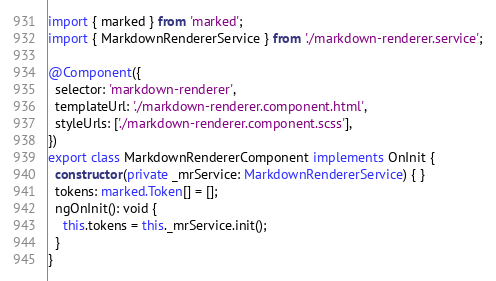<code> <loc_0><loc_0><loc_500><loc_500><_TypeScript_>import { marked } from 'marked';
import { MarkdownRendererService } from './markdown-renderer.service';

@Component({
  selector: 'markdown-renderer',
  templateUrl: './markdown-renderer.component.html',
  styleUrls: ['./markdown-renderer.component.scss'],
})
export class MarkdownRendererComponent implements OnInit {
  constructor(private _mrService: MarkdownRendererService) { }
  tokens: marked.Token[] = [];
  ngOnInit(): void {
    this.tokens = this._mrService.init();
  }
}
</code> 